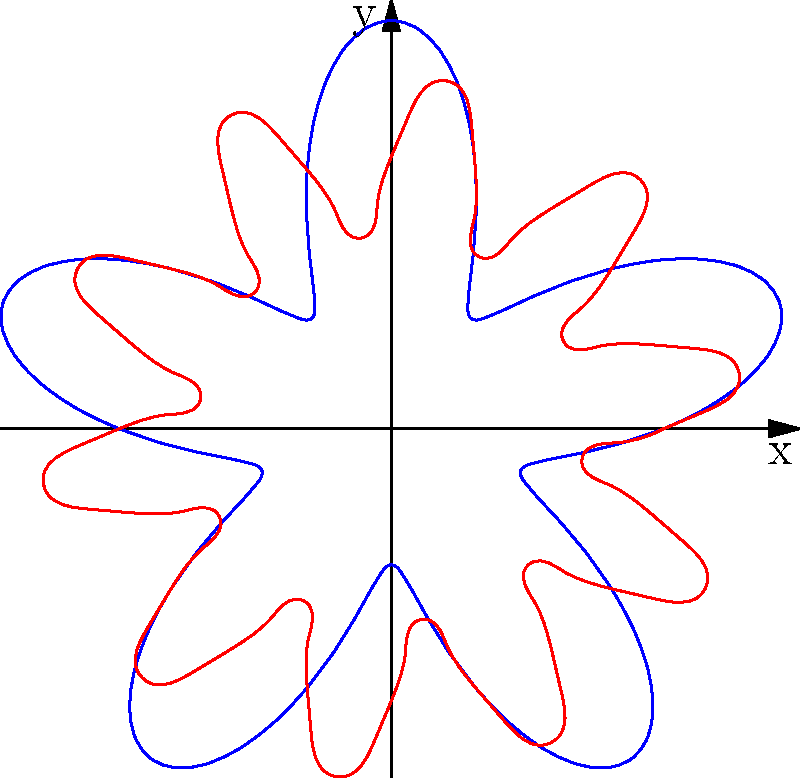In the polar coordinate graph above, two sound wave patterns are represented. The blue curve corresponds to a classic techno beat, while the red curve represents a drum and bass rhythm. Which genre typically has a higher frequency of beats per minute (BPM)? To answer this question, we need to analyze the polar coordinate representations of the two sound wave patterns:

1. The blue curve (classic techno beat) is described by the equation $r = 1 + 0.5\sin(5t)$.
2. The red curve (drum and bass rhythm) is described by the equation $r = 1 + 0.3\sin(10t)$.

The key difference between these equations is the frequency of the sine function:

- For the blue curve (techno), the frequency is 5.
- For the red curve (drum and bass), the frequency is 10.

In polar coordinates, a higher frequency means more oscillations per revolution, which translates to more beats per minute in music.

The red curve (drum and bass) has a higher frequency (10) compared to the blue curve (5), indicating that it has more beats per revolution and thus a higher BPM.

This aligns with the typical characteristics of these genres:
- Techno usually ranges from 120-150 BPM.
- Drum and bass typically has a faster tempo, ranging from 160-180 BPM.

Therefore, the genre with the higher frequency of beats per minute is drum and bass, represented by the red curve.
Answer: Drum and bass 